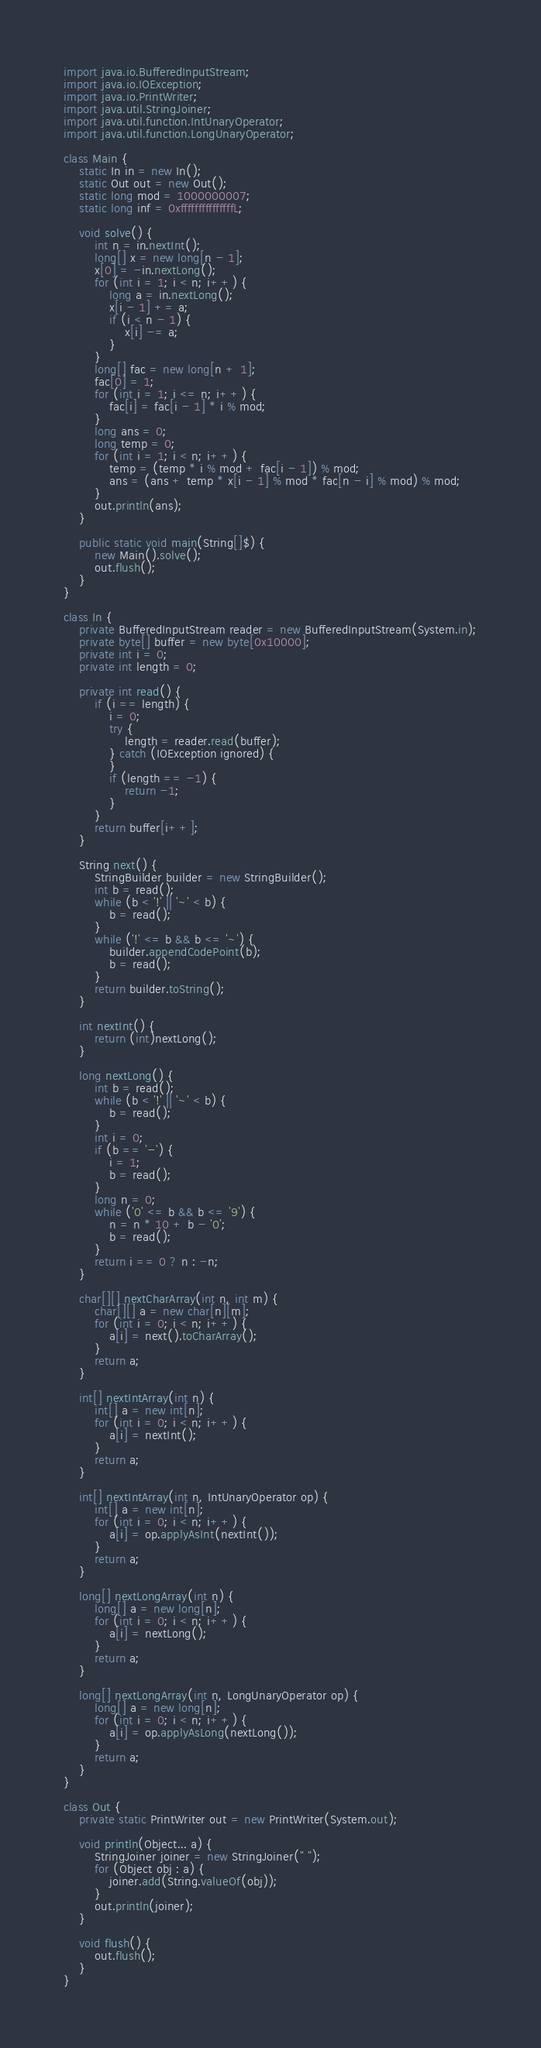<code> <loc_0><loc_0><loc_500><loc_500><_Java_>import java.io.BufferedInputStream;
import java.io.IOException;
import java.io.PrintWriter;
import java.util.StringJoiner;
import java.util.function.IntUnaryOperator;
import java.util.function.LongUnaryOperator;

class Main {
    static In in = new In();
    static Out out = new Out();
    static long mod = 1000000007;
    static long inf = 0xfffffffffffffffL;

    void solve() {
        int n = in.nextInt();
        long[] x = new long[n - 1];
        x[0] = -in.nextLong();
        for (int i = 1; i < n; i++) {
            long a = in.nextLong();
            x[i - 1] += a;
            if (i < n - 1) {
                x[i] -= a;
            }
        }
        long[] fac = new long[n + 1];
        fac[0] = 1;
        for (int i = 1; i <= n; i++) {
            fac[i] = fac[i - 1] * i % mod;
        }
        long ans = 0;
        long temp = 0;
        for (int i = 1; i < n; i++) {
            temp = (temp * i % mod + fac[i - 1]) % mod;
            ans = (ans + temp * x[i - 1] % mod * fac[n - i] % mod) % mod;
        }
        out.println(ans);
    }

    public static void main(String[]$) {
        new Main().solve();
        out.flush();
    }
}

class In {
    private BufferedInputStream reader = new BufferedInputStream(System.in);
    private byte[] buffer = new byte[0x10000];
    private int i = 0;
    private int length = 0;

    private int read() {
        if (i == length) {
            i = 0;
            try {
                length = reader.read(buffer);
            } catch (IOException ignored) {
            }
            if (length == -1) {
                return -1;
            }
        }
        return buffer[i++];
    }

    String next() {
        StringBuilder builder = new StringBuilder();
        int b = read();
        while (b < '!' || '~' < b) {
            b = read();
        }
        while ('!' <= b && b <= '~') {
            builder.appendCodePoint(b);
            b = read();
        }
        return builder.toString();
    }

    int nextInt() {
        return (int)nextLong();
    }

    long nextLong() {
        int b = read();
        while (b < '!' || '~' < b) {
            b = read();
        }
        int i = 0;
        if (b == '-') {
            i = 1;
            b = read();
        }
        long n = 0;
        while ('0' <= b && b <= '9') {
            n = n * 10 + b - '0';
            b = read();
        }
        return i == 0 ? n : -n;
    }

    char[][] nextCharArray(int n, int m) {
        char[][] a = new char[n][m];
        for (int i = 0; i < n; i++) {
            a[i] = next().toCharArray();
        }
        return a;
    }

    int[] nextIntArray(int n) {
        int[] a = new int[n];
        for (int i = 0; i < n; i++) {
            a[i] = nextInt();
        }
        return a;
    }

    int[] nextIntArray(int n, IntUnaryOperator op) {
        int[] a = new int[n];
        for (int i = 0; i < n; i++) {
            a[i] = op.applyAsInt(nextInt());
        }
        return a;
    }

    long[] nextLongArray(int n) {
        long[] a = new long[n];
        for (int i = 0; i < n; i++) {
            a[i] = nextLong();
        }
        return a;
    }

    long[] nextLongArray(int n, LongUnaryOperator op) {
        long[] a = new long[n];
        for (int i = 0; i < n; i++) {
            a[i] = op.applyAsLong(nextLong());
        }
        return a;
    }
}

class Out {
    private static PrintWriter out = new PrintWriter(System.out);

    void println(Object... a) {
        StringJoiner joiner = new StringJoiner(" ");
        for (Object obj : a) {
            joiner.add(String.valueOf(obj));
        }
        out.println(joiner);
    }

    void flush() {
        out.flush();
    }
}
</code> 